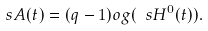Convert formula to latex. <formula><loc_0><loc_0><loc_500><loc_500>\ s A ( t ) = ( q - 1 ) \L o g ( \ s H ^ { 0 } ( t ) ) .</formula> 